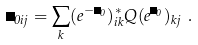<formula> <loc_0><loc_0><loc_500><loc_500>\Phi _ { 0 i j } = \sum _ { k } ( e ^ { - \Psi _ { 0 } } ) _ { i k } ^ { * } Q ( e ^ { \Psi _ { 0 } } ) _ { k j } \ .</formula> 